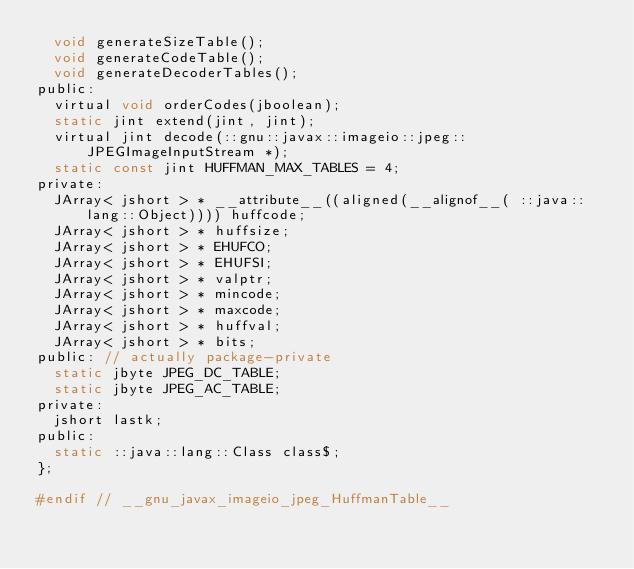Convert code to text. <code><loc_0><loc_0><loc_500><loc_500><_C_>  void generateSizeTable();
  void generateCodeTable();
  void generateDecoderTables();
public:
  virtual void orderCodes(jboolean);
  static jint extend(jint, jint);
  virtual jint decode(::gnu::javax::imageio::jpeg::JPEGImageInputStream *);
  static const jint HUFFMAN_MAX_TABLES = 4;
private:
  JArray< jshort > * __attribute__((aligned(__alignof__( ::java::lang::Object)))) huffcode;
  JArray< jshort > * huffsize;
  JArray< jshort > * EHUFCO;
  JArray< jshort > * EHUFSI;
  JArray< jshort > * valptr;
  JArray< jshort > * mincode;
  JArray< jshort > * maxcode;
  JArray< jshort > * huffval;
  JArray< jshort > * bits;
public: // actually package-private
  static jbyte JPEG_DC_TABLE;
  static jbyte JPEG_AC_TABLE;
private:
  jshort lastk;
public:
  static ::java::lang::Class class$;
};

#endif // __gnu_javax_imageio_jpeg_HuffmanTable__
</code> 